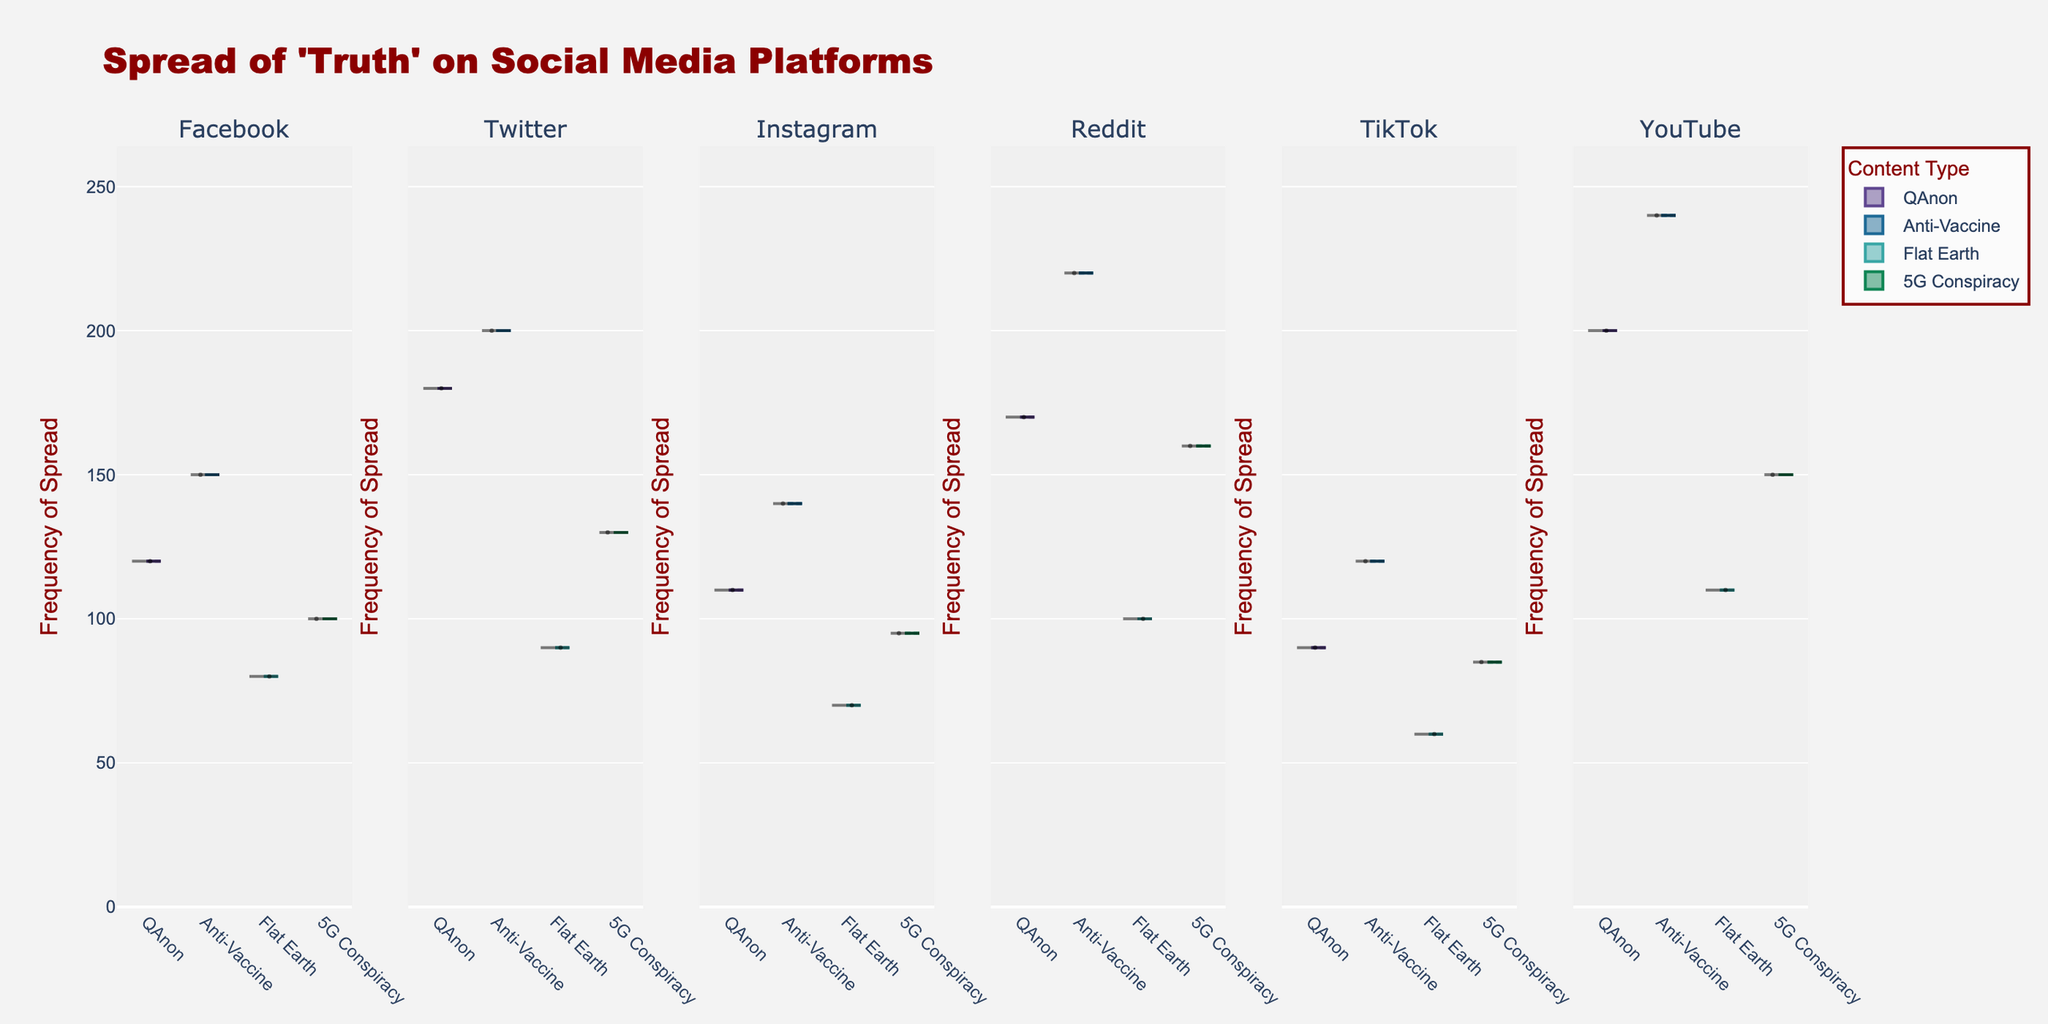What is the title of the figure? The title of the figure is prominently displayed at the top center of the plot.
Answer: Spread of 'Truth' on Social Media Platforms Which platform has the highest frequency of Anti-Vaccine content spread? Look at the maximum distribution in the violin plot for each platform's Anti-Vaccine content. The highest spread is visible on the Reddit platform.
Answer: Reddit What is the frequency range of QAnon conspiracy spread on YouTube? Examine the violin plot for QAnon on YouTube; the range is from the minimum to maximum frequency values.
Answer: 200 Compare the median frequency of Flat Earth content spread between Facebook and Instagram. Which platform has a higher median? Observe the median lines (often marked inside the box plots) for the Flat Earth content on both platforms. Facebook has a higher median frequency compared to Instagram.
Answer: Facebook Which platform shows the widest spread (most variance) for 5G conspiracy content? Check the width and spread of the 5G conspiracy violin plots across all platforms. The platform with the widest spread appears to be Reddit.
Answer: Reddit What is the average frequency of 5G conspiracy content spread on Facebook and Twitter? Sum the frequencies of 5G on Facebook (100) and Twitter (130), then divide by 2. (100 + 130) / 2 = 115
Answer: 115 Which content type has the highest spread on TikTok? Look at the highest point of the violin plots for TikTok across all content types. Anti-Vaccine shows the highest spread.
Answer: Anti-Vaccine How does the spread of QAnon content on Twitter compare to Instagram? Compare the widths and median lines of the QAnon content on Twitter and Instagram. Twitter shows a higher and more varied spread.
Answer: Twitter Are there any platforms where the median spread of any content types are almost the same? Check all the median lines in the box plots to see if any medians across content types are very close on any platform. The medians for QAnon and 5G Conspiracy on Facebook are quite close.
Answer: Facebook What is the interquartile range (IQR) of Anti-Vaccine content on YouTube? Examine the box plot for Anti-Vaccine content on YouTube, focusing on the length of the box (IQR), which represents the range between the first and third quartiles.
Answer: 40 